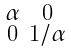<formula> <loc_0><loc_0><loc_500><loc_500>\begin{smallmatrix} \alpha & 0 \\ 0 & 1 / \alpha \end{smallmatrix}</formula> 